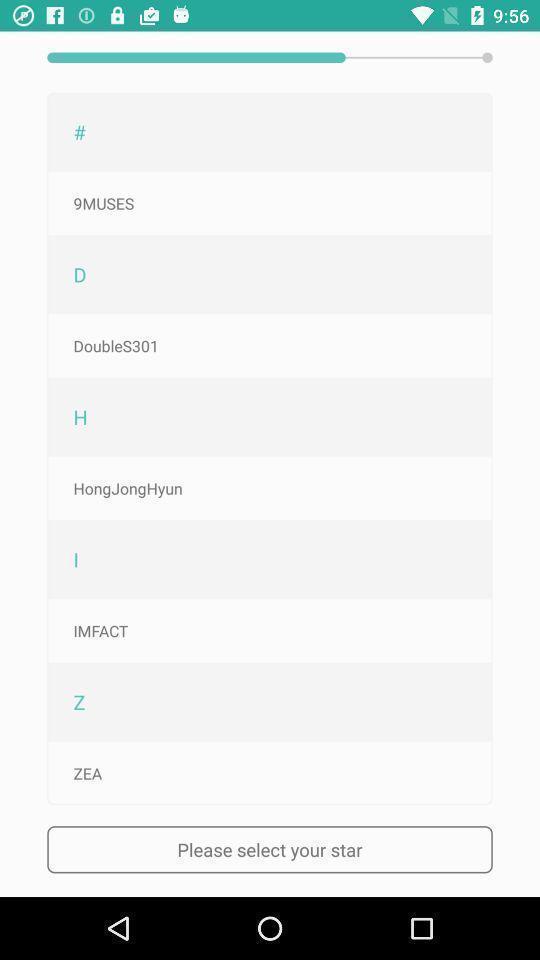Tell me about the visual elements in this screen capture. Star selection page in a fans app. 